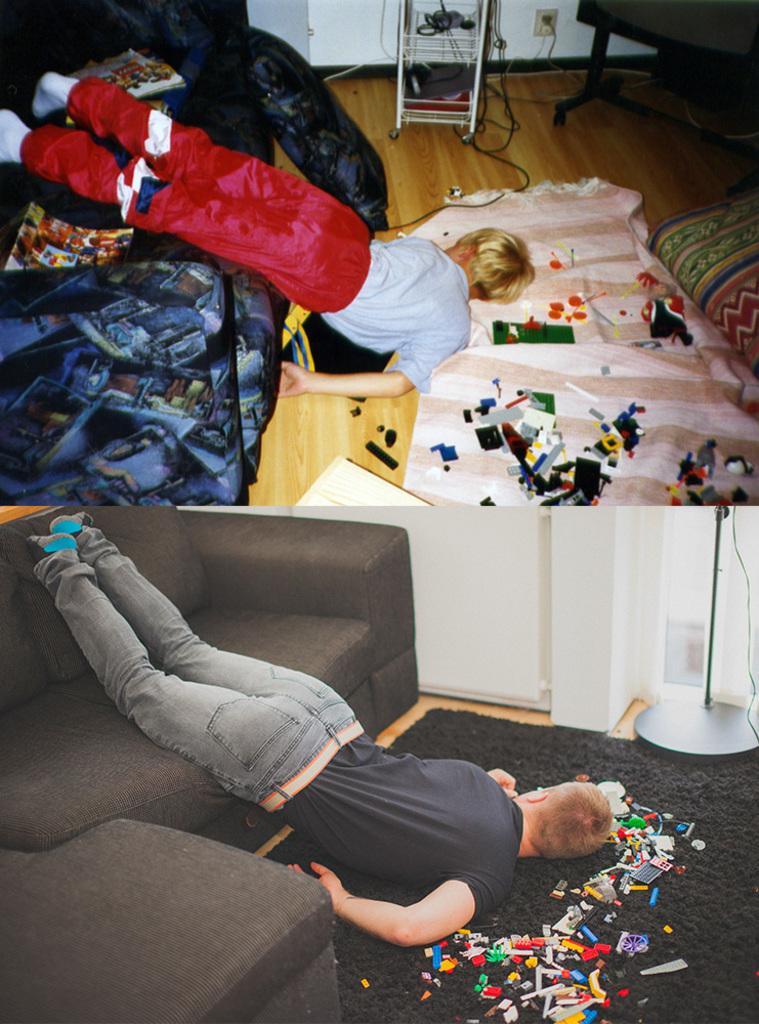Please provide a concise description of this image. This is the collage of two pictures where there are two boys lying vertically from the sofa to the floor on which there are some papers. 